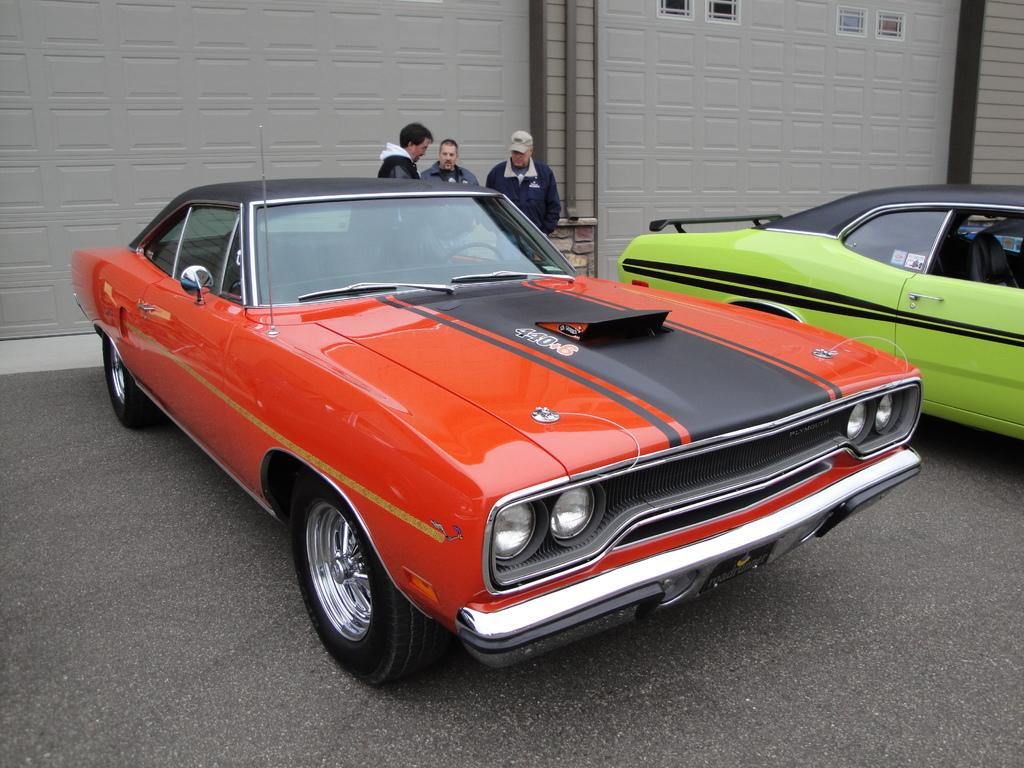What can be seen in the middle of the image? There are cars on the road in the center of the image. What else is visible in the image besides the cars? There are people and a building in the background of the image. What type of punishment is being handed out in the image? There is no indication of punishment in the image; it features cars on the road and people in the background. 